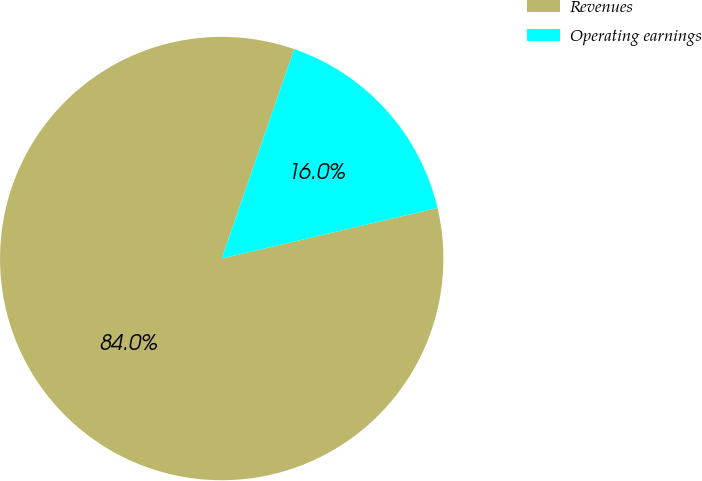Convert chart. <chart><loc_0><loc_0><loc_500><loc_500><pie_chart><fcel>Revenues<fcel>Operating earnings<nl><fcel>83.97%<fcel>16.03%<nl></chart> 